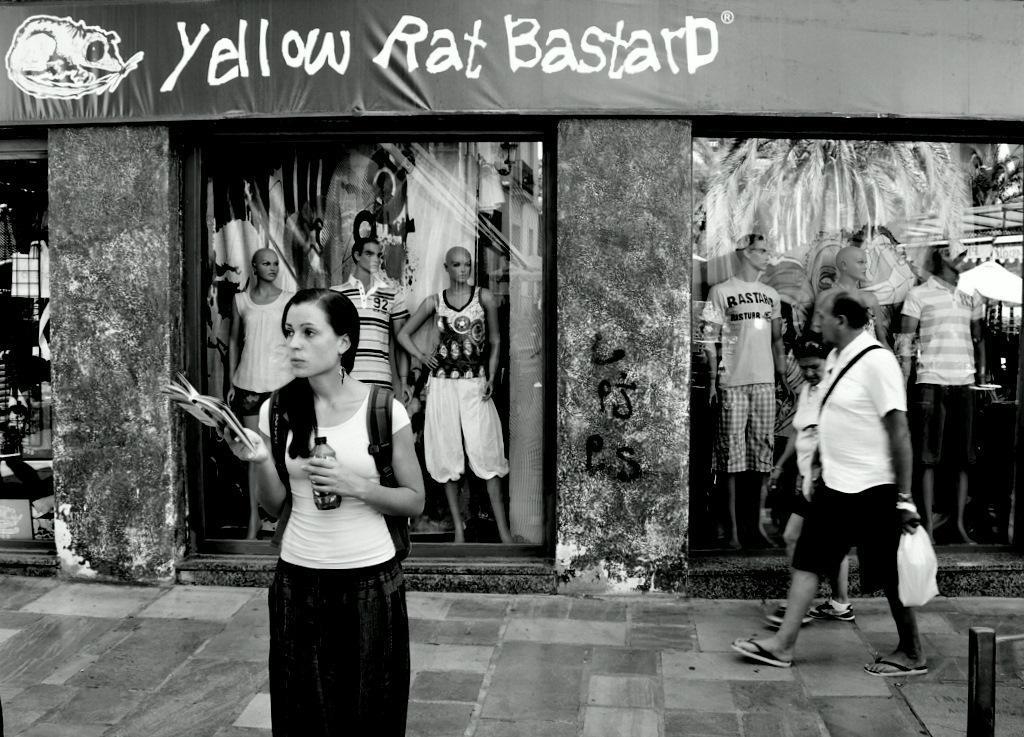How would you summarize this image in a sentence or two? This is a black and white picture. Here we can see few persons. There are mannequins, clothes, pillars, and a board. 